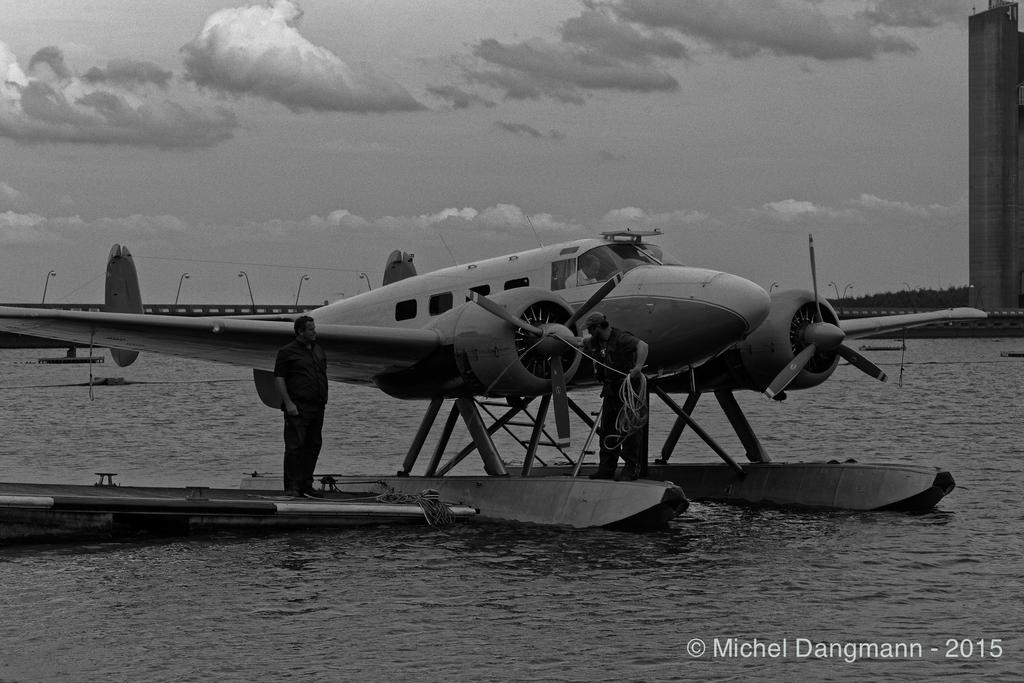Provide a one-sentence caption for the provided image. a black and white old sea plane taken by Michel Dangmann in 2015. 